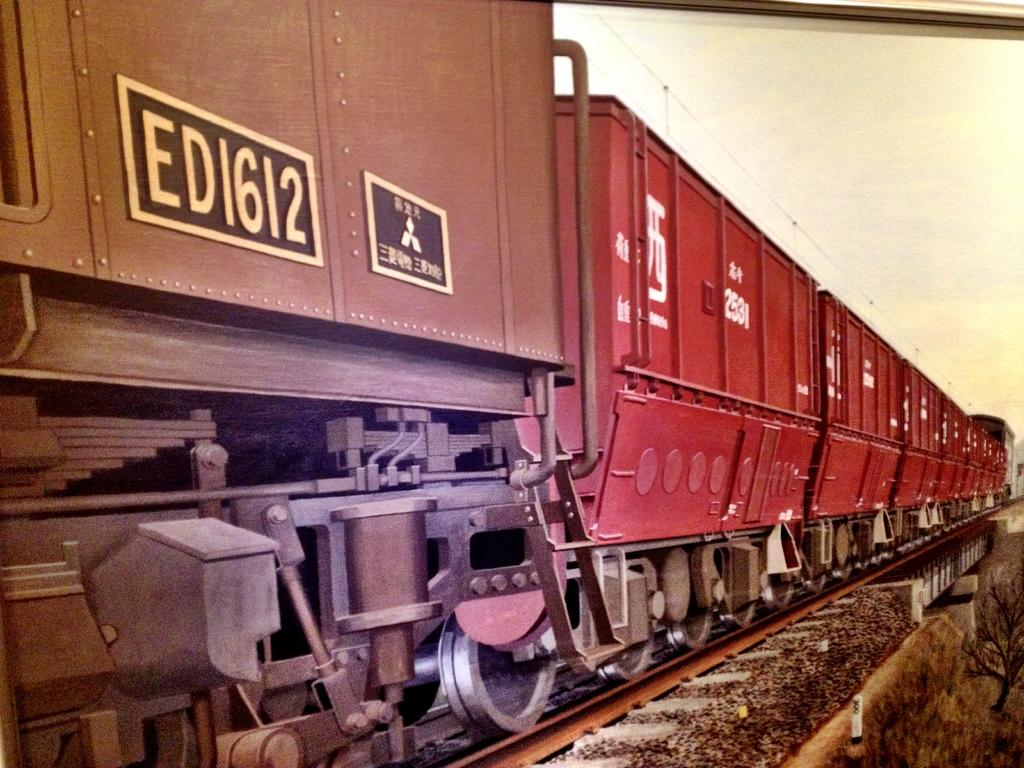What is the main subject of the image? The main subject of the image is a train. Can you describe the train's location in the image? The train is on a track. What type of song can be heard playing in the aftermath of the train's journey in the image? There is no indication of a song or any sound in the image, as it features a train on a track. 